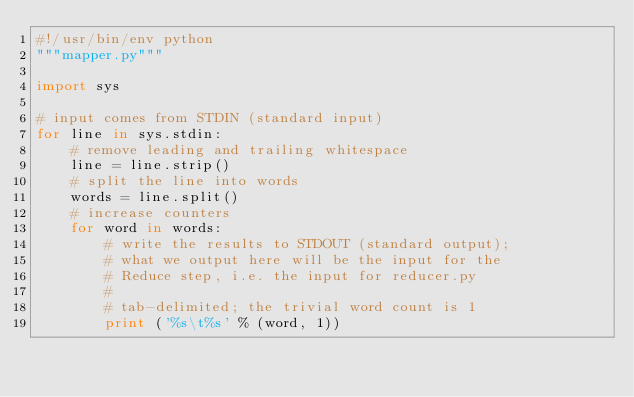Convert code to text. <code><loc_0><loc_0><loc_500><loc_500><_Python_>#!/usr/bin/env python
"""mapper.py"""

import sys

# input comes from STDIN (standard input)
for line in sys.stdin:
    # remove leading and trailing whitespace
    line = line.strip()
    # split the line into words
    words = line.split()
    # increase counters
    for word in words:
        # write the results to STDOUT (standard output);
        # what we output here will be the input for the
        # Reduce step, i.e. the input for reducer.py
        #
        # tab-delimited; the trivial word count is 1
        print ('%s\t%s' % (word, 1))</code> 